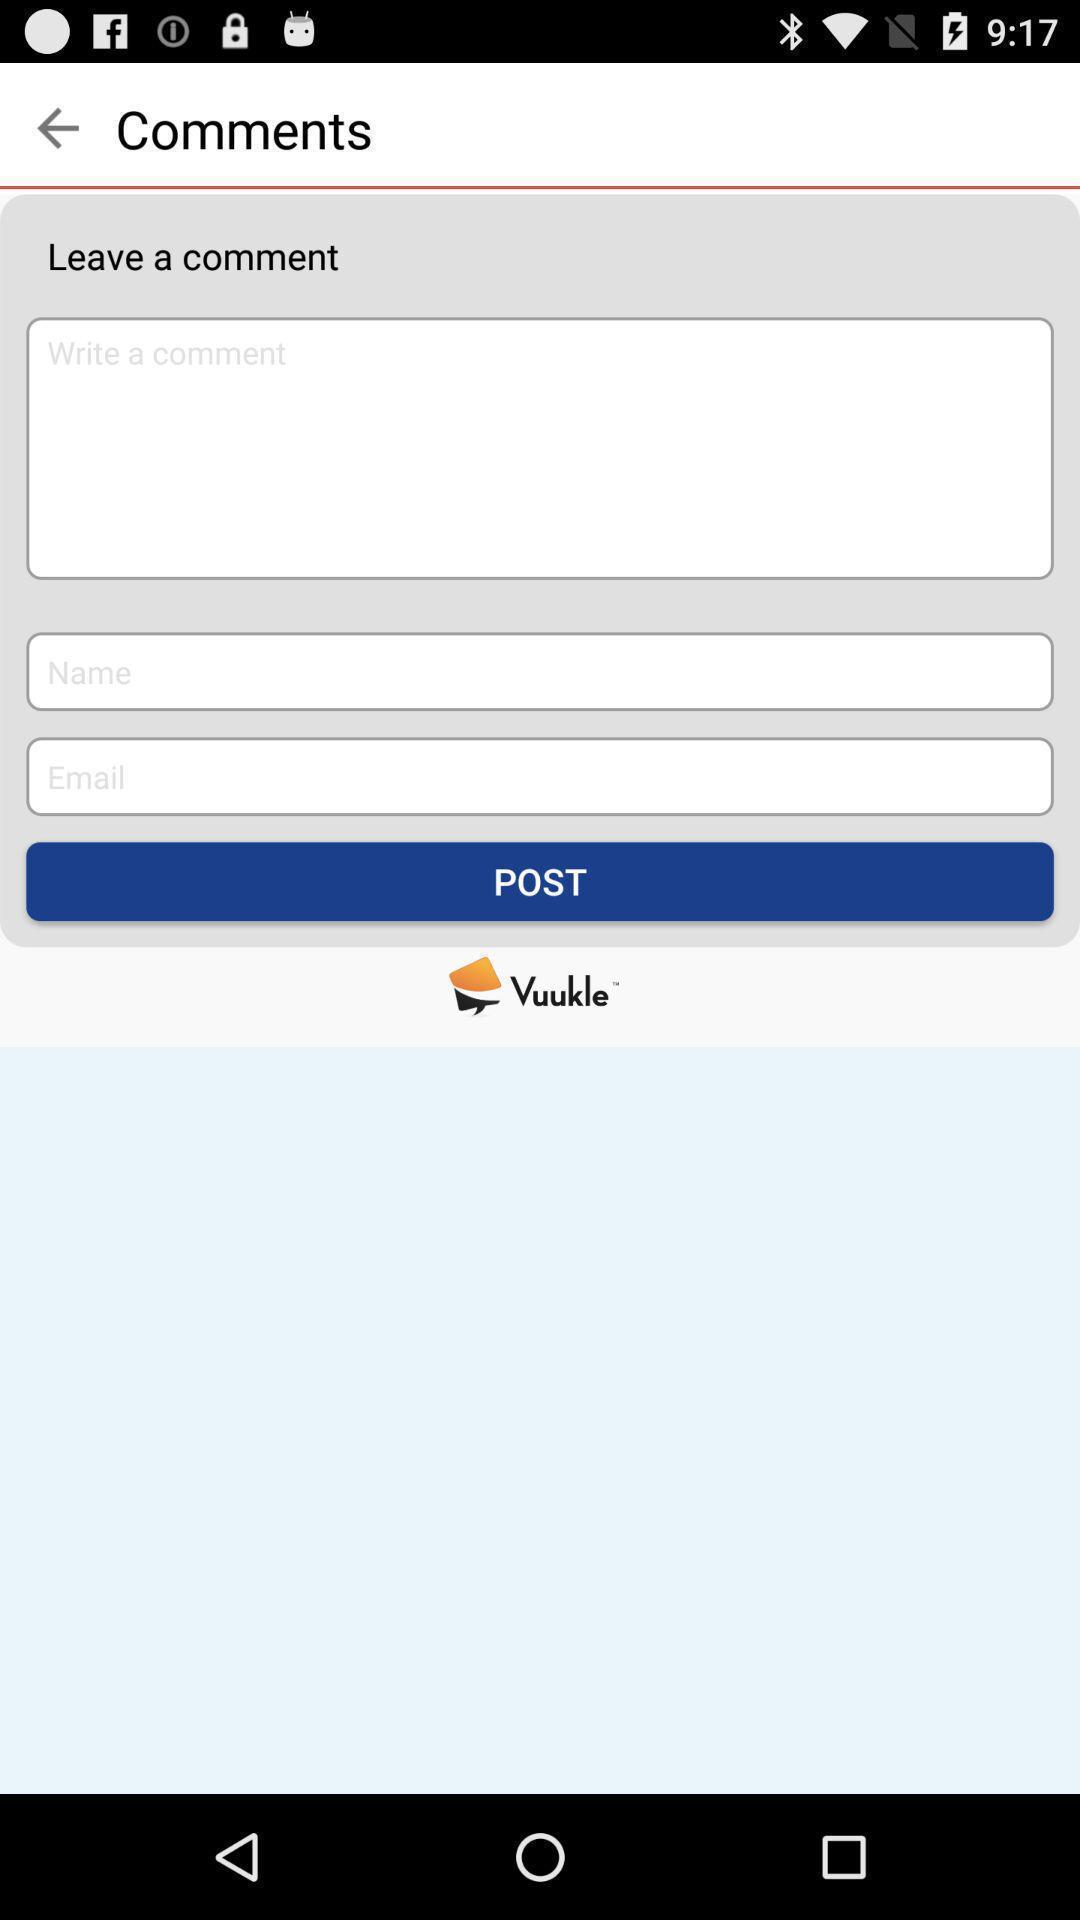Summarize the information in this screenshot. Page shows comments and post button in an news application. 